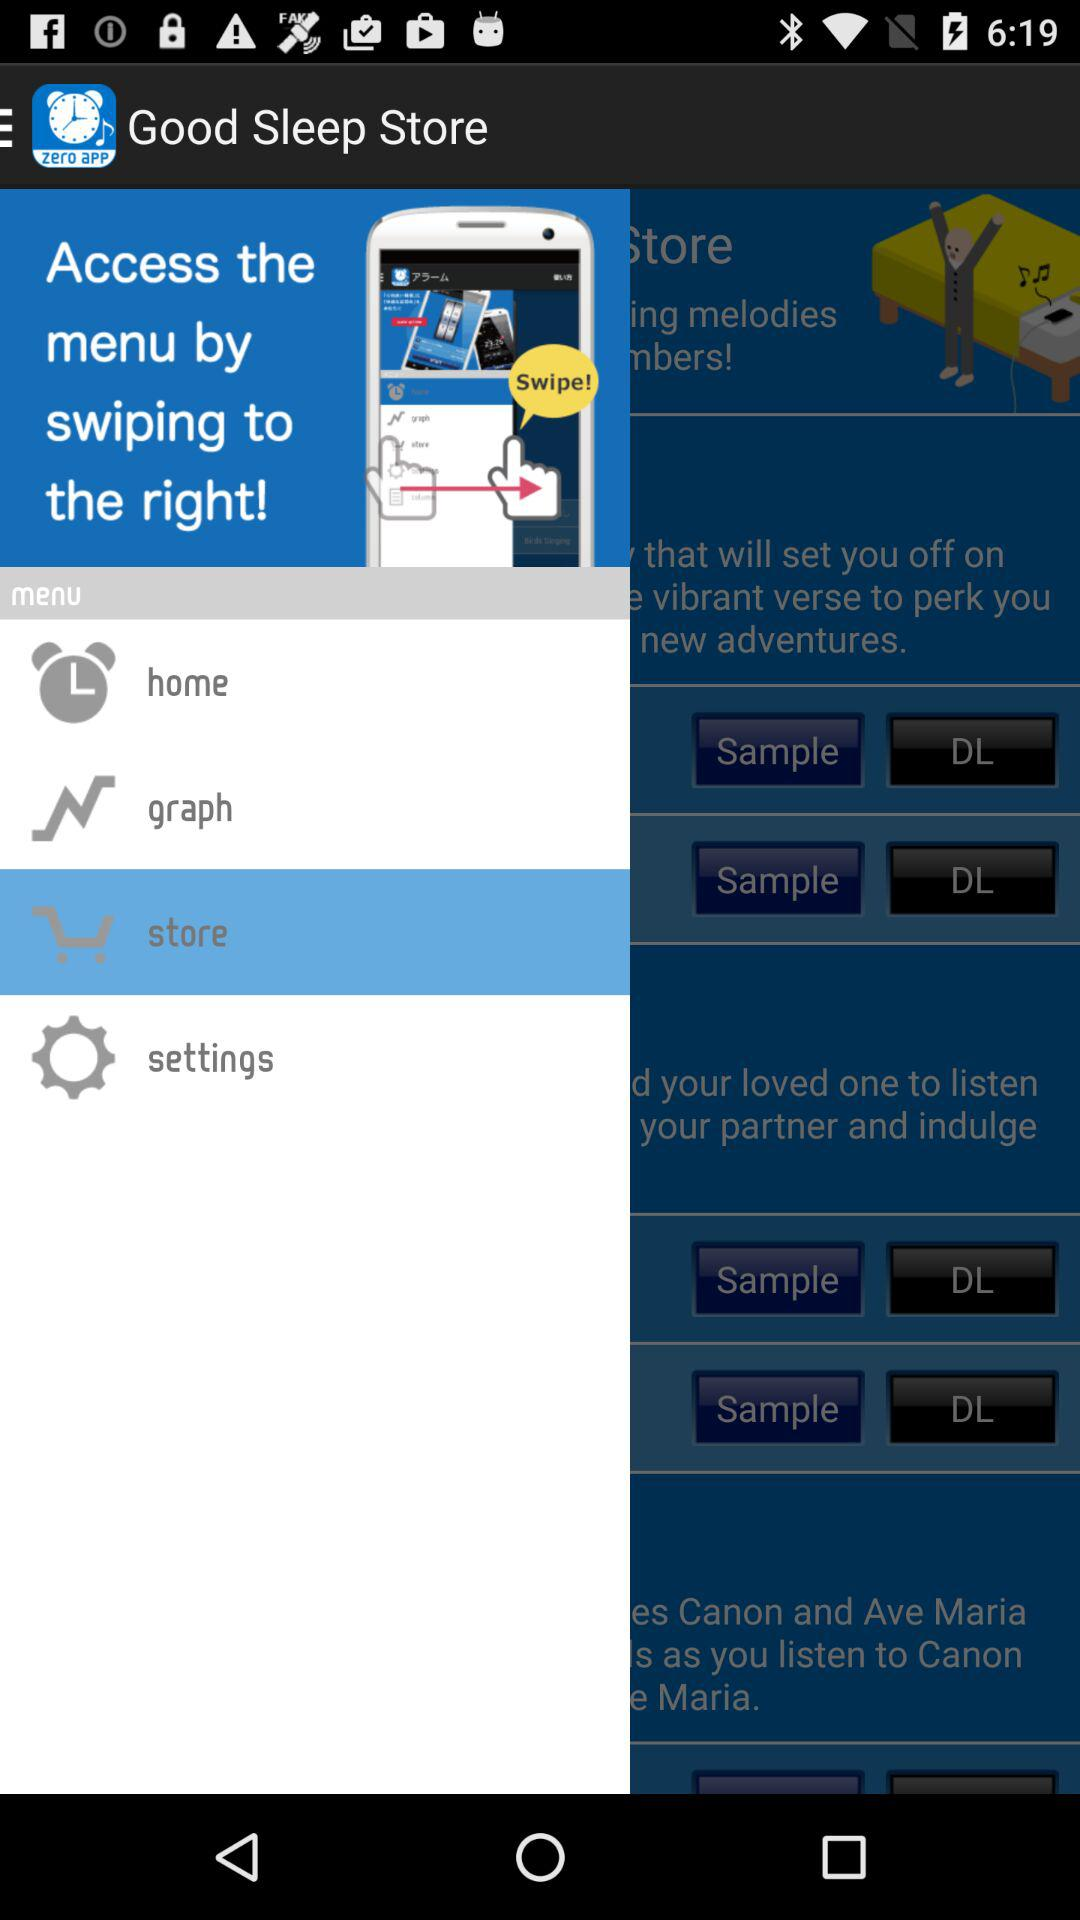How can the menu be accessed? The menu can be accessed by swiping to the right. 